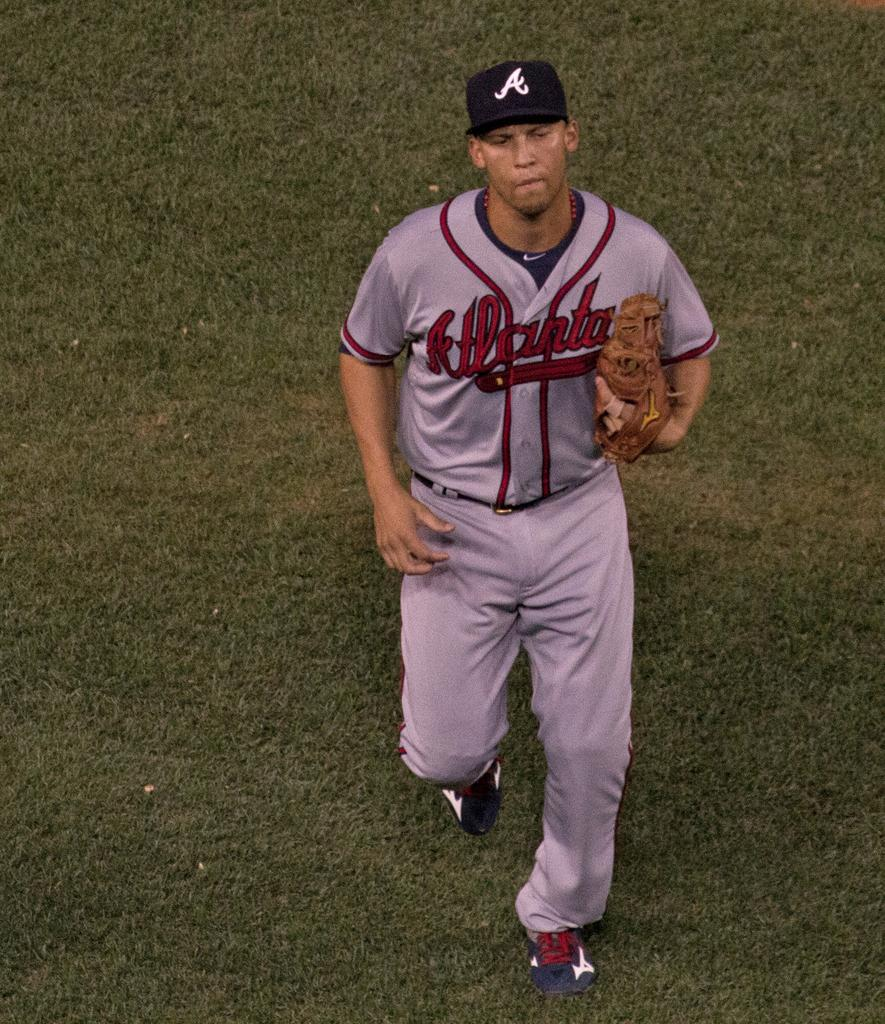<image>
Describe the image concisely. An Atlanta baseball player is running on the baseball field. 